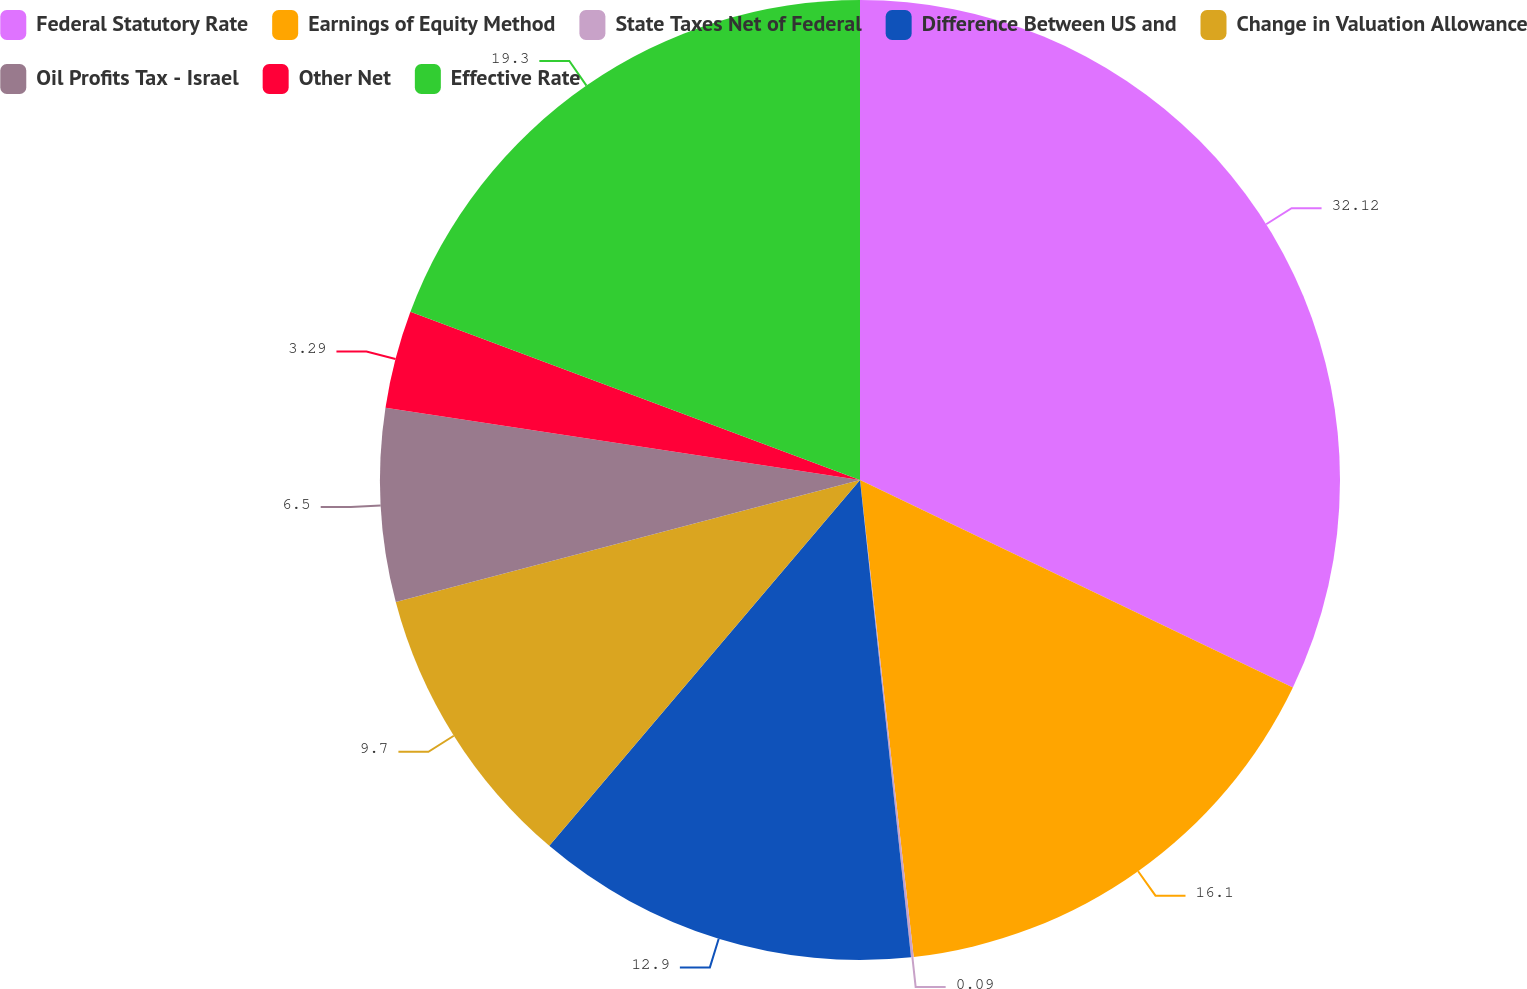Convert chart. <chart><loc_0><loc_0><loc_500><loc_500><pie_chart><fcel>Federal Statutory Rate<fcel>Earnings of Equity Method<fcel>State Taxes Net of Federal<fcel>Difference Between US and<fcel>Change in Valuation Allowance<fcel>Oil Profits Tax - Israel<fcel>Other Net<fcel>Effective Rate<nl><fcel>32.11%<fcel>16.1%<fcel>0.09%<fcel>12.9%<fcel>9.7%<fcel>6.5%<fcel>3.29%<fcel>19.3%<nl></chart> 